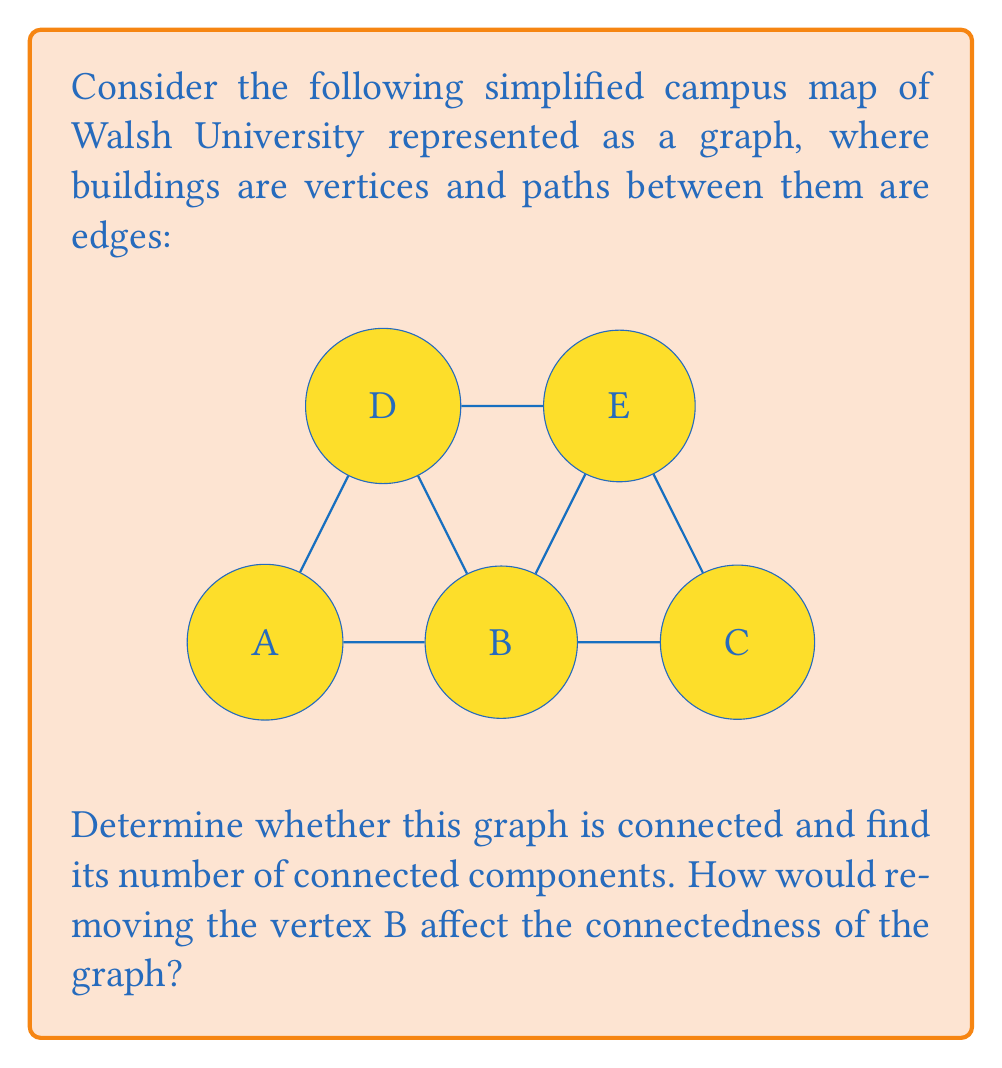Give your solution to this math problem. To determine the connectedness of the campus map graph, we need to analyze whether there exists a path between every pair of vertices.

1. Initial graph analysis:
   - The graph has 5 vertices (A, B, C, D, E) representing campus buildings.
   - There are 7 edges representing paths between buildings.

2. Connectedness check:
   - We can observe that there is a path between any two vertices in the graph.
   - For example, to go from A to C, we can follow the path A-B-C.
   - Similarly, all other pairs of vertices are connected by at least one path.

3. Number of connected components:
   - Since all vertices are reachable from any other vertex, the graph has only one connected component.
   - Mathematically, we can express this as: $\text{Number of connected components} = 1$

4. Effect of removing vertex B:
   - If we remove vertex B and all its incident edges, the graph becomes:
     [asy]
     unitsize(1cm);
     pair A = (0,0), C = (4,0), D = (1,2), E = (3,2);
     draw(A--D--E--C);
     label("A", A, SW);
     label("C", C, SE);
     label("D", D, NW);
     label("E", E, NE);
     [/asy]
   - In this new graph, we can still reach any vertex from any other vertex.
   - For example, to go from A to C, we can now follow the path A-D-E-C.
   - The graph remains connected, and the number of connected components is still 1.

Therefore, the original graph is connected with one connected component, and removing vertex B does not affect its connectedness.
Answer: The graph is connected with 1 connected component. Removing vertex B does not affect the connectedness; the resulting graph remains connected with 1 connected component. 